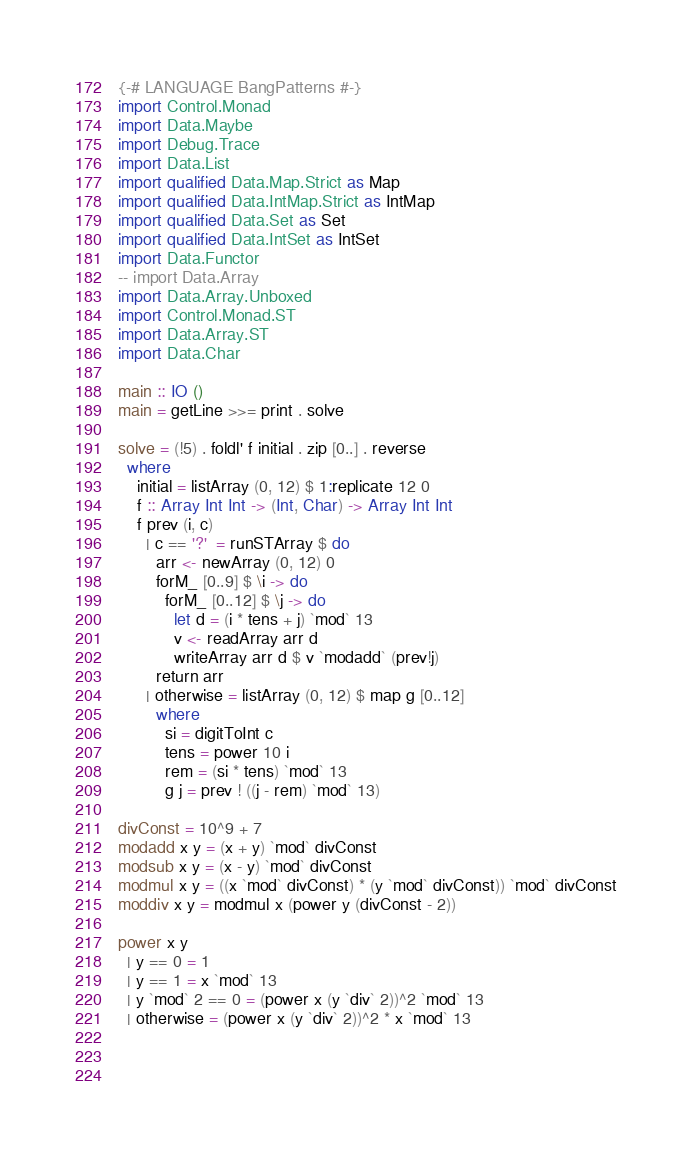<code> <loc_0><loc_0><loc_500><loc_500><_Haskell_>{-# LANGUAGE BangPatterns #-}
import Control.Monad
import Data.Maybe
import Debug.Trace
import Data.List
import qualified Data.Map.Strict as Map
import qualified Data.IntMap.Strict as IntMap
import qualified Data.Set as Set
import qualified Data.IntSet as IntSet
import Data.Functor
-- import Data.Array
import Data.Array.Unboxed
import Control.Monad.ST
import Data.Array.ST
import Data.Char

main :: IO ()
main = getLine >>= print . solve

solve = (!5) . foldl' f initial . zip [0..] . reverse 
  where
    initial = listArray (0, 12) $ 1:replicate 12 0
    f :: Array Int Int -> (Int, Char) -> Array Int Int
    f prev (i, c)
      | c == '?'  = runSTArray $ do
        arr <- newArray (0, 12) 0
        forM_ [0..9] $ \i -> do
          forM_ [0..12] $ \j -> do
            let d = (i * tens + j) `mod` 13
            v <- readArray arr d
            writeArray arr d $ v `modadd` (prev!j)
        return arr
      | otherwise = listArray (0, 12) $ map g [0..12]
        where
          si = digitToInt c
          tens = power 10 i
          rem = (si * tens) `mod` 13
          g j = prev ! ((j - rem) `mod` 13)

divConst = 10^9 + 7
modadd x y = (x + y) `mod` divConst
modsub x y = (x - y) `mod` divConst
modmul x y = ((x `mod` divConst) * (y `mod` divConst)) `mod` divConst
moddiv x y = modmul x (power y (divConst - 2))

power x y
  | y == 0 = 1
  | y == 1 = x `mod` 13
  | y `mod` 2 == 0 = (power x (y `div` 2))^2 `mod` 13
  | otherwise = (power x (y `div` 2))^2 * x `mod` 13
          

    
</code> 